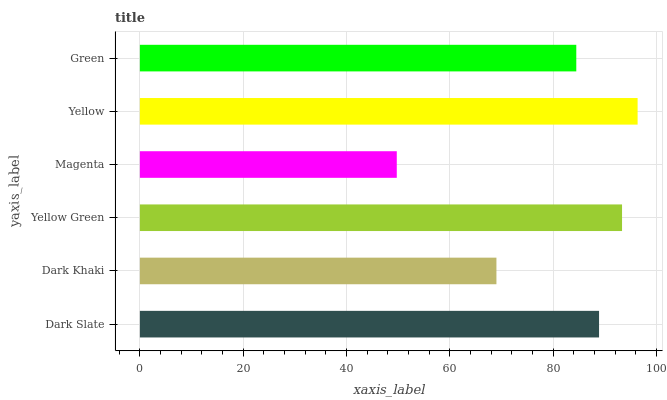Is Magenta the minimum?
Answer yes or no. Yes. Is Yellow the maximum?
Answer yes or no. Yes. Is Dark Khaki the minimum?
Answer yes or no. No. Is Dark Khaki the maximum?
Answer yes or no. No. Is Dark Slate greater than Dark Khaki?
Answer yes or no. Yes. Is Dark Khaki less than Dark Slate?
Answer yes or no. Yes. Is Dark Khaki greater than Dark Slate?
Answer yes or no. No. Is Dark Slate less than Dark Khaki?
Answer yes or no. No. Is Dark Slate the high median?
Answer yes or no. Yes. Is Green the low median?
Answer yes or no. Yes. Is Dark Khaki the high median?
Answer yes or no. No. Is Yellow Green the low median?
Answer yes or no. No. 